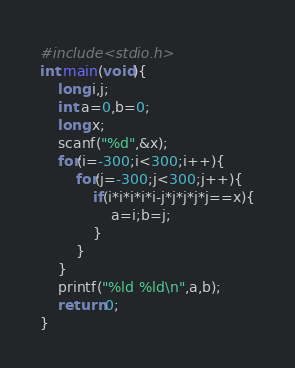Convert code to text. <code><loc_0><loc_0><loc_500><loc_500><_C_>#include<stdio.h>
int main(void){
	long i,j;
	int a=0,b=0;
	long x;
	scanf("%d",&x);
	for(i=-300;i<300;i++){
		for(j=-300;j<300;j++){
			if(i*i*i*i*i-j*j*j*j*j==x){
				a=i;b=j;
			}
		}
	}
	printf("%ld %ld\n",a,b);
	return 0;
}
</code> 